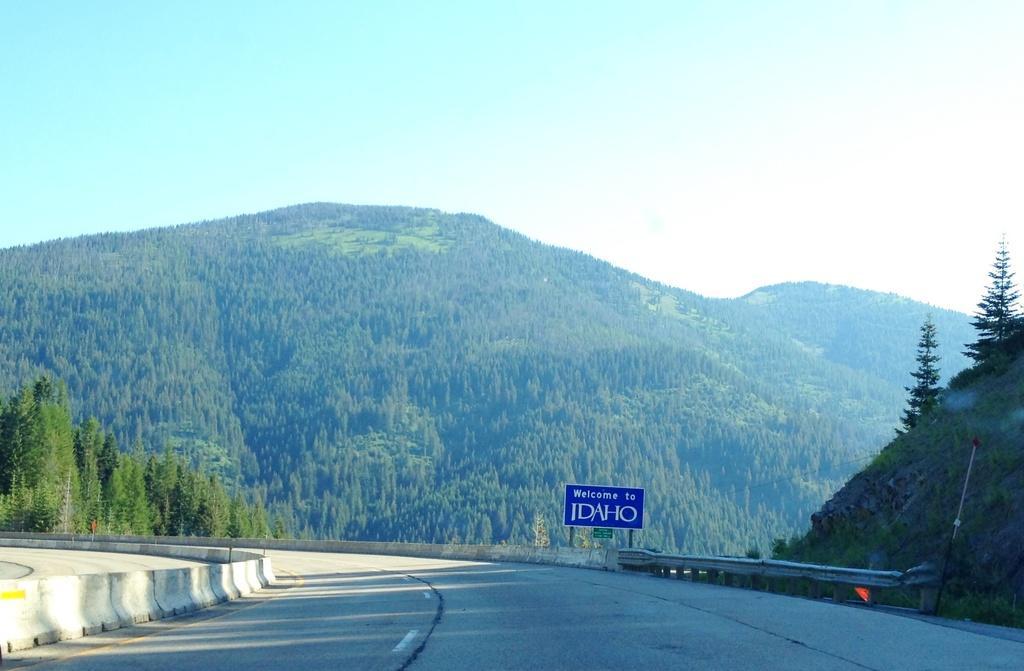Describe this image in one or two sentences. In this image there is the sky towards the top of the image, there are mountains, there are trees on the mountains, there is road towards the bottom of the image, there is a board, there is text on the board, there are plants towards the right of the image, there are trees towards the right of the image. 